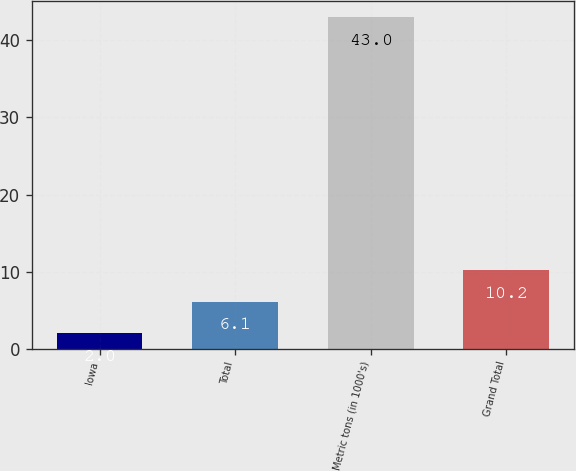Convert chart. <chart><loc_0><loc_0><loc_500><loc_500><bar_chart><fcel>Iowa<fcel>Total<fcel>Metric tons (in 1000's)<fcel>Grand Total<nl><fcel>2<fcel>6.1<fcel>43<fcel>10.2<nl></chart> 